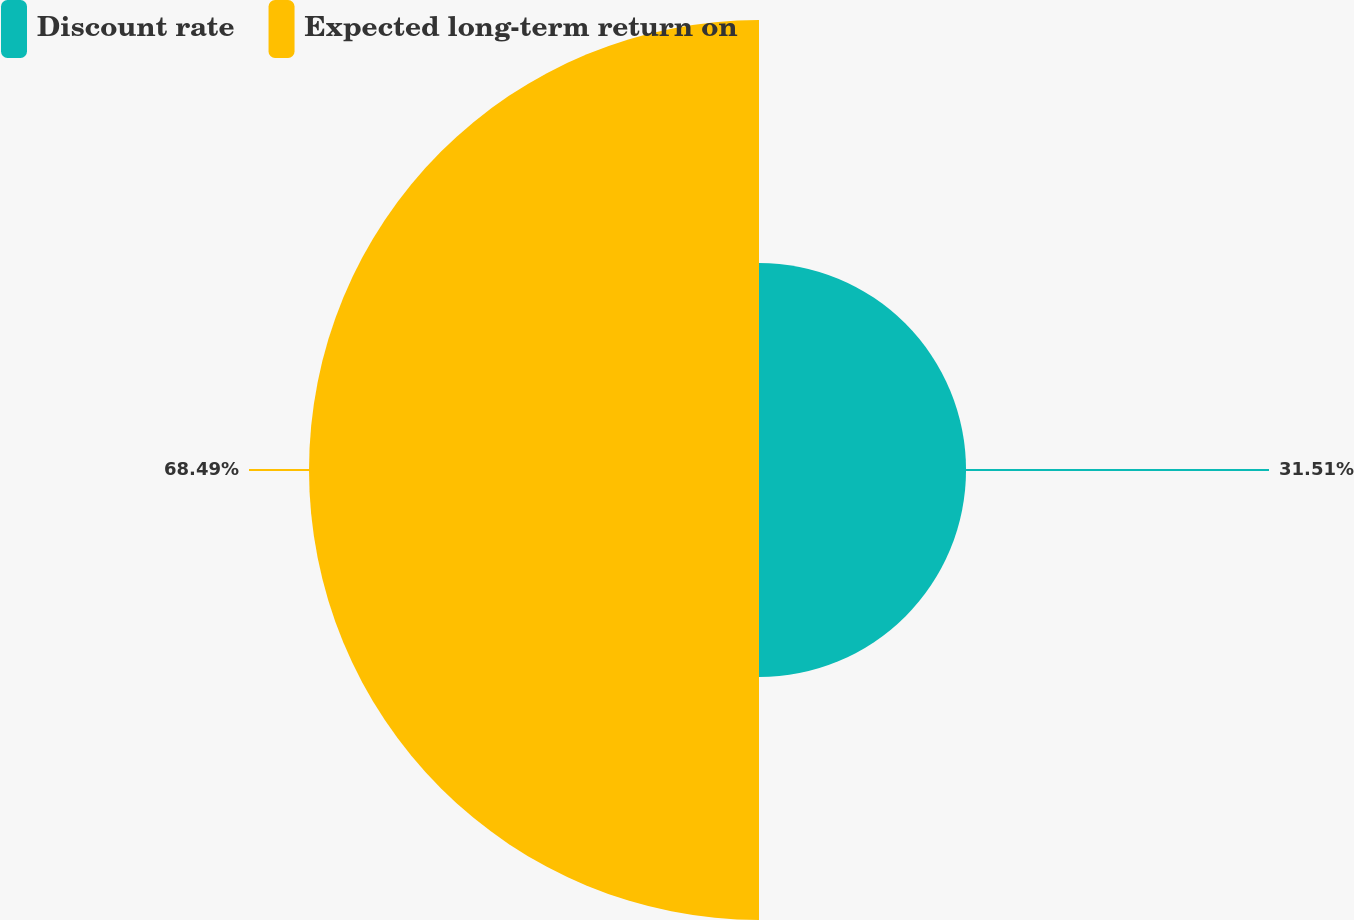Convert chart. <chart><loc_0><loc_0><loc_500><loc_500><pie_chart><fcel>Discount rate<fcel>Expected long-term return on<nl><fcel>31.51%<fcel>68.49%<nl></chart> 